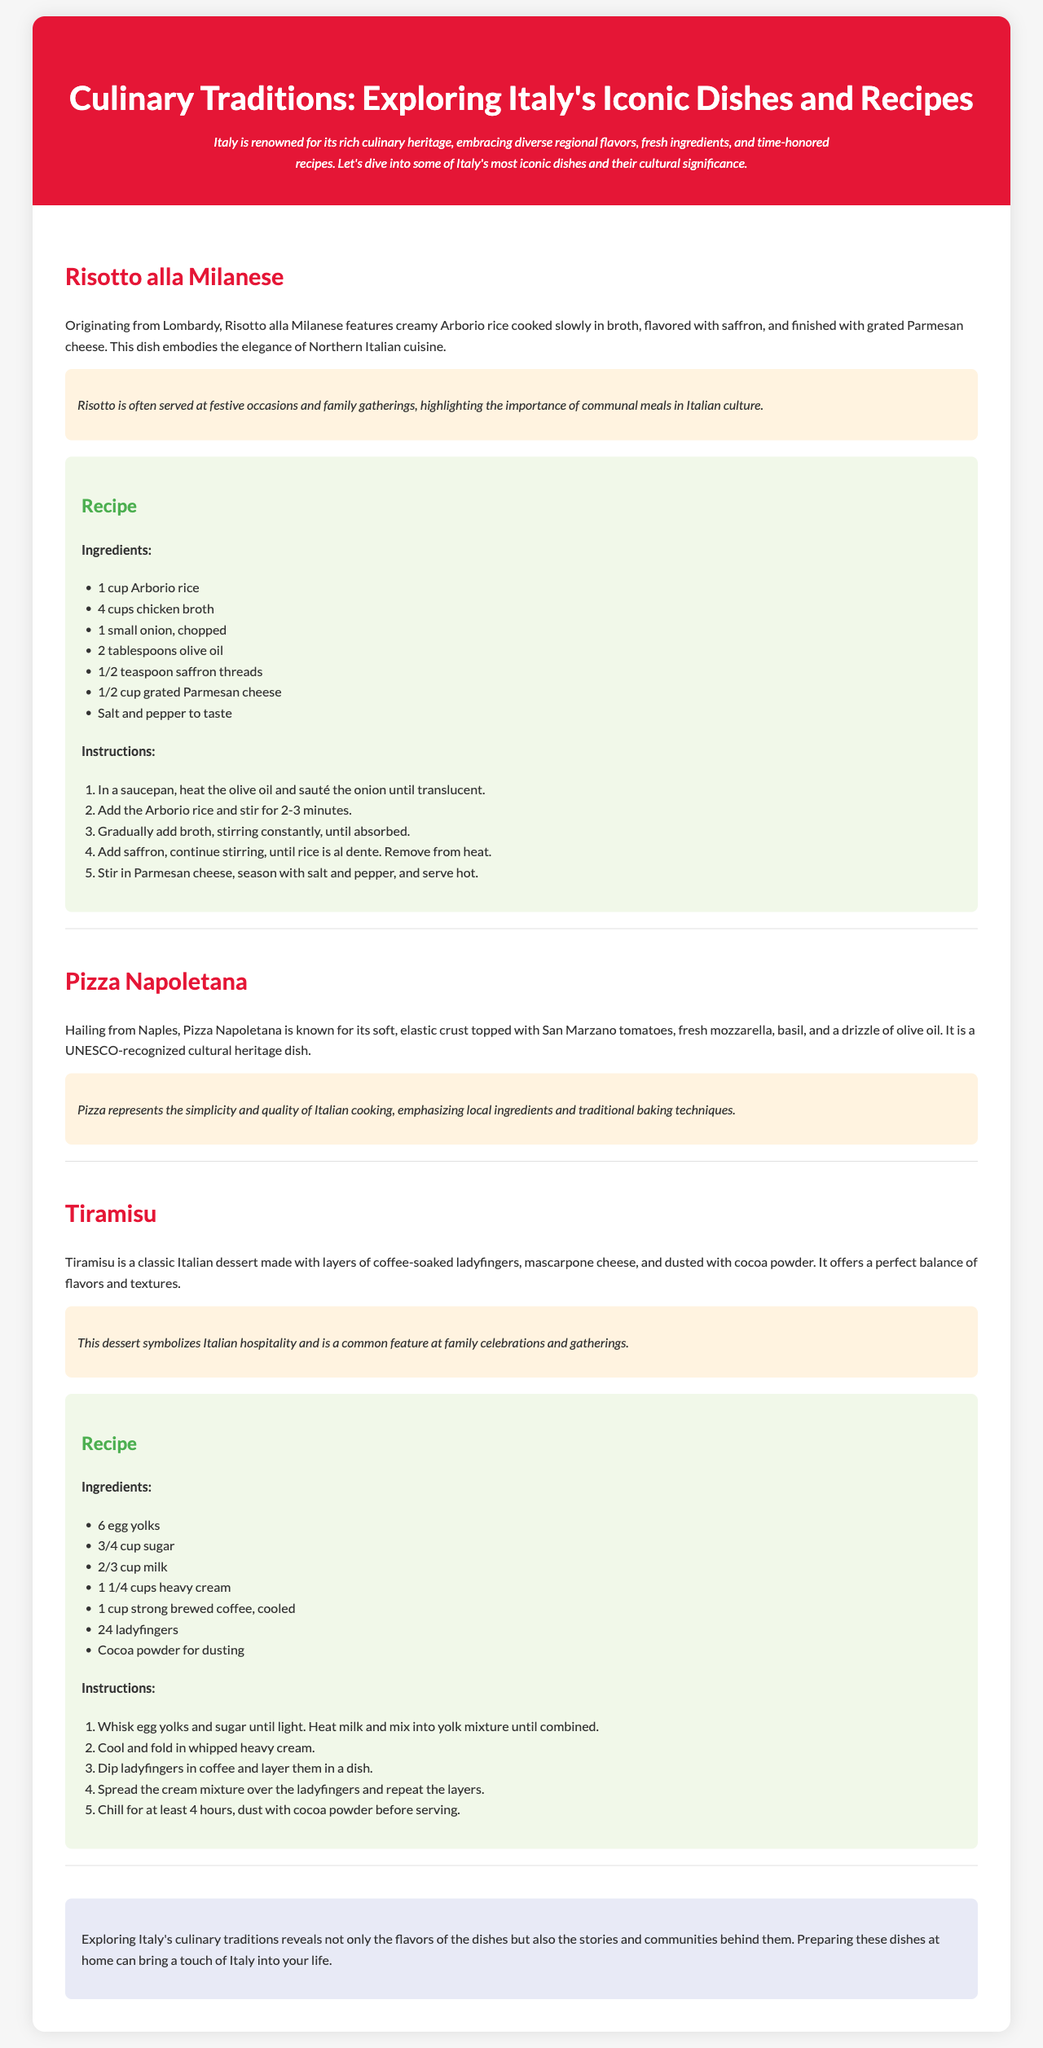what is the title of the brochure? The title is presented at the top in a prominent header, indicating the main focus of the content.
Answer: Culinary Traditions: Exploring Italy's Iconic Dishes and Recipes how many iconic dishes are mentioned in the brochure? The brochure describes three specific dishes in separate sections, detailing each one.
Answer: 3 what key ingredient is highlighted in Risotto alla Milanese? The brochure specifies saffron as a significant ingredient that flavors the dish.
Answer: saffron what is the cultural significance of Pizza Napoletana? The document states that Pizza represents simplicity and quality in Italian cooking.
Answer: simplicity and quality how long should Tiramisu be chilled before serving? The instructions mention a specific time requirement for chilling the dessert before it's ready.
Answer: 4 hours 